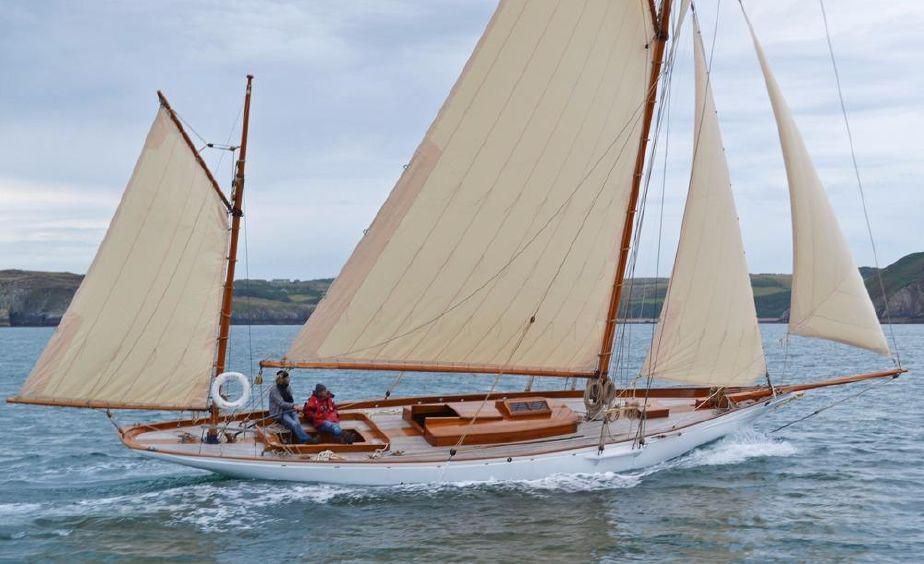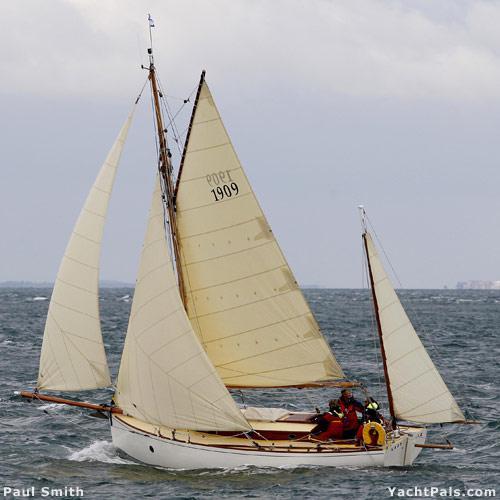The first image is the image on the left, the second image is the image on the right. Examine the images to the left and right. Is the description "There is a landform visible behind the boat in one of the images." accurate? Answer yes or no. Yes. The first image is the image on the left, the second image is the image on the right. Given the left and right images, does the statement "One image shows a boat with exactly three sails." hold true? Answer yes or no. No. 